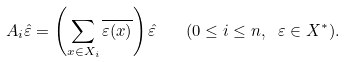<formula> <loc_0><loc_0><loc_500><loc_500>A _ { i } \hat { \varepsilon } = \left ( \sum _ { x \in X _ { i } } \overline { \varepsilon ( x ) } \right ) \hat { \varepsilon } \quad ( 0 \leq i \leq n , \ \varepsilon \in X ^ { * } ) .</formula> 